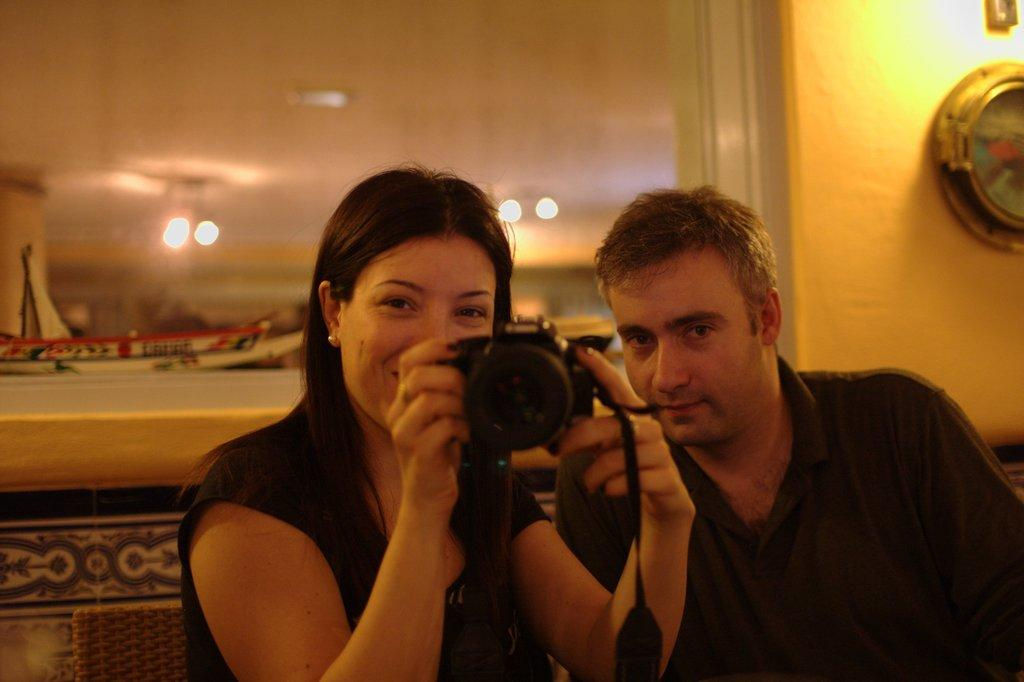Who is the main subject in the image? There is a woman in the image. What is the woman doing in the image? The woman is holding a camera and taking a picture. Who else is present in the image? There is a man in the image. What can be seen in the background of the image? There is a wall and a frame in the background of the image. What type of paint is being used by the woman in the image? There is no paint or painting activity depicted in the image; the woman is holding a camera and taking a picture. 